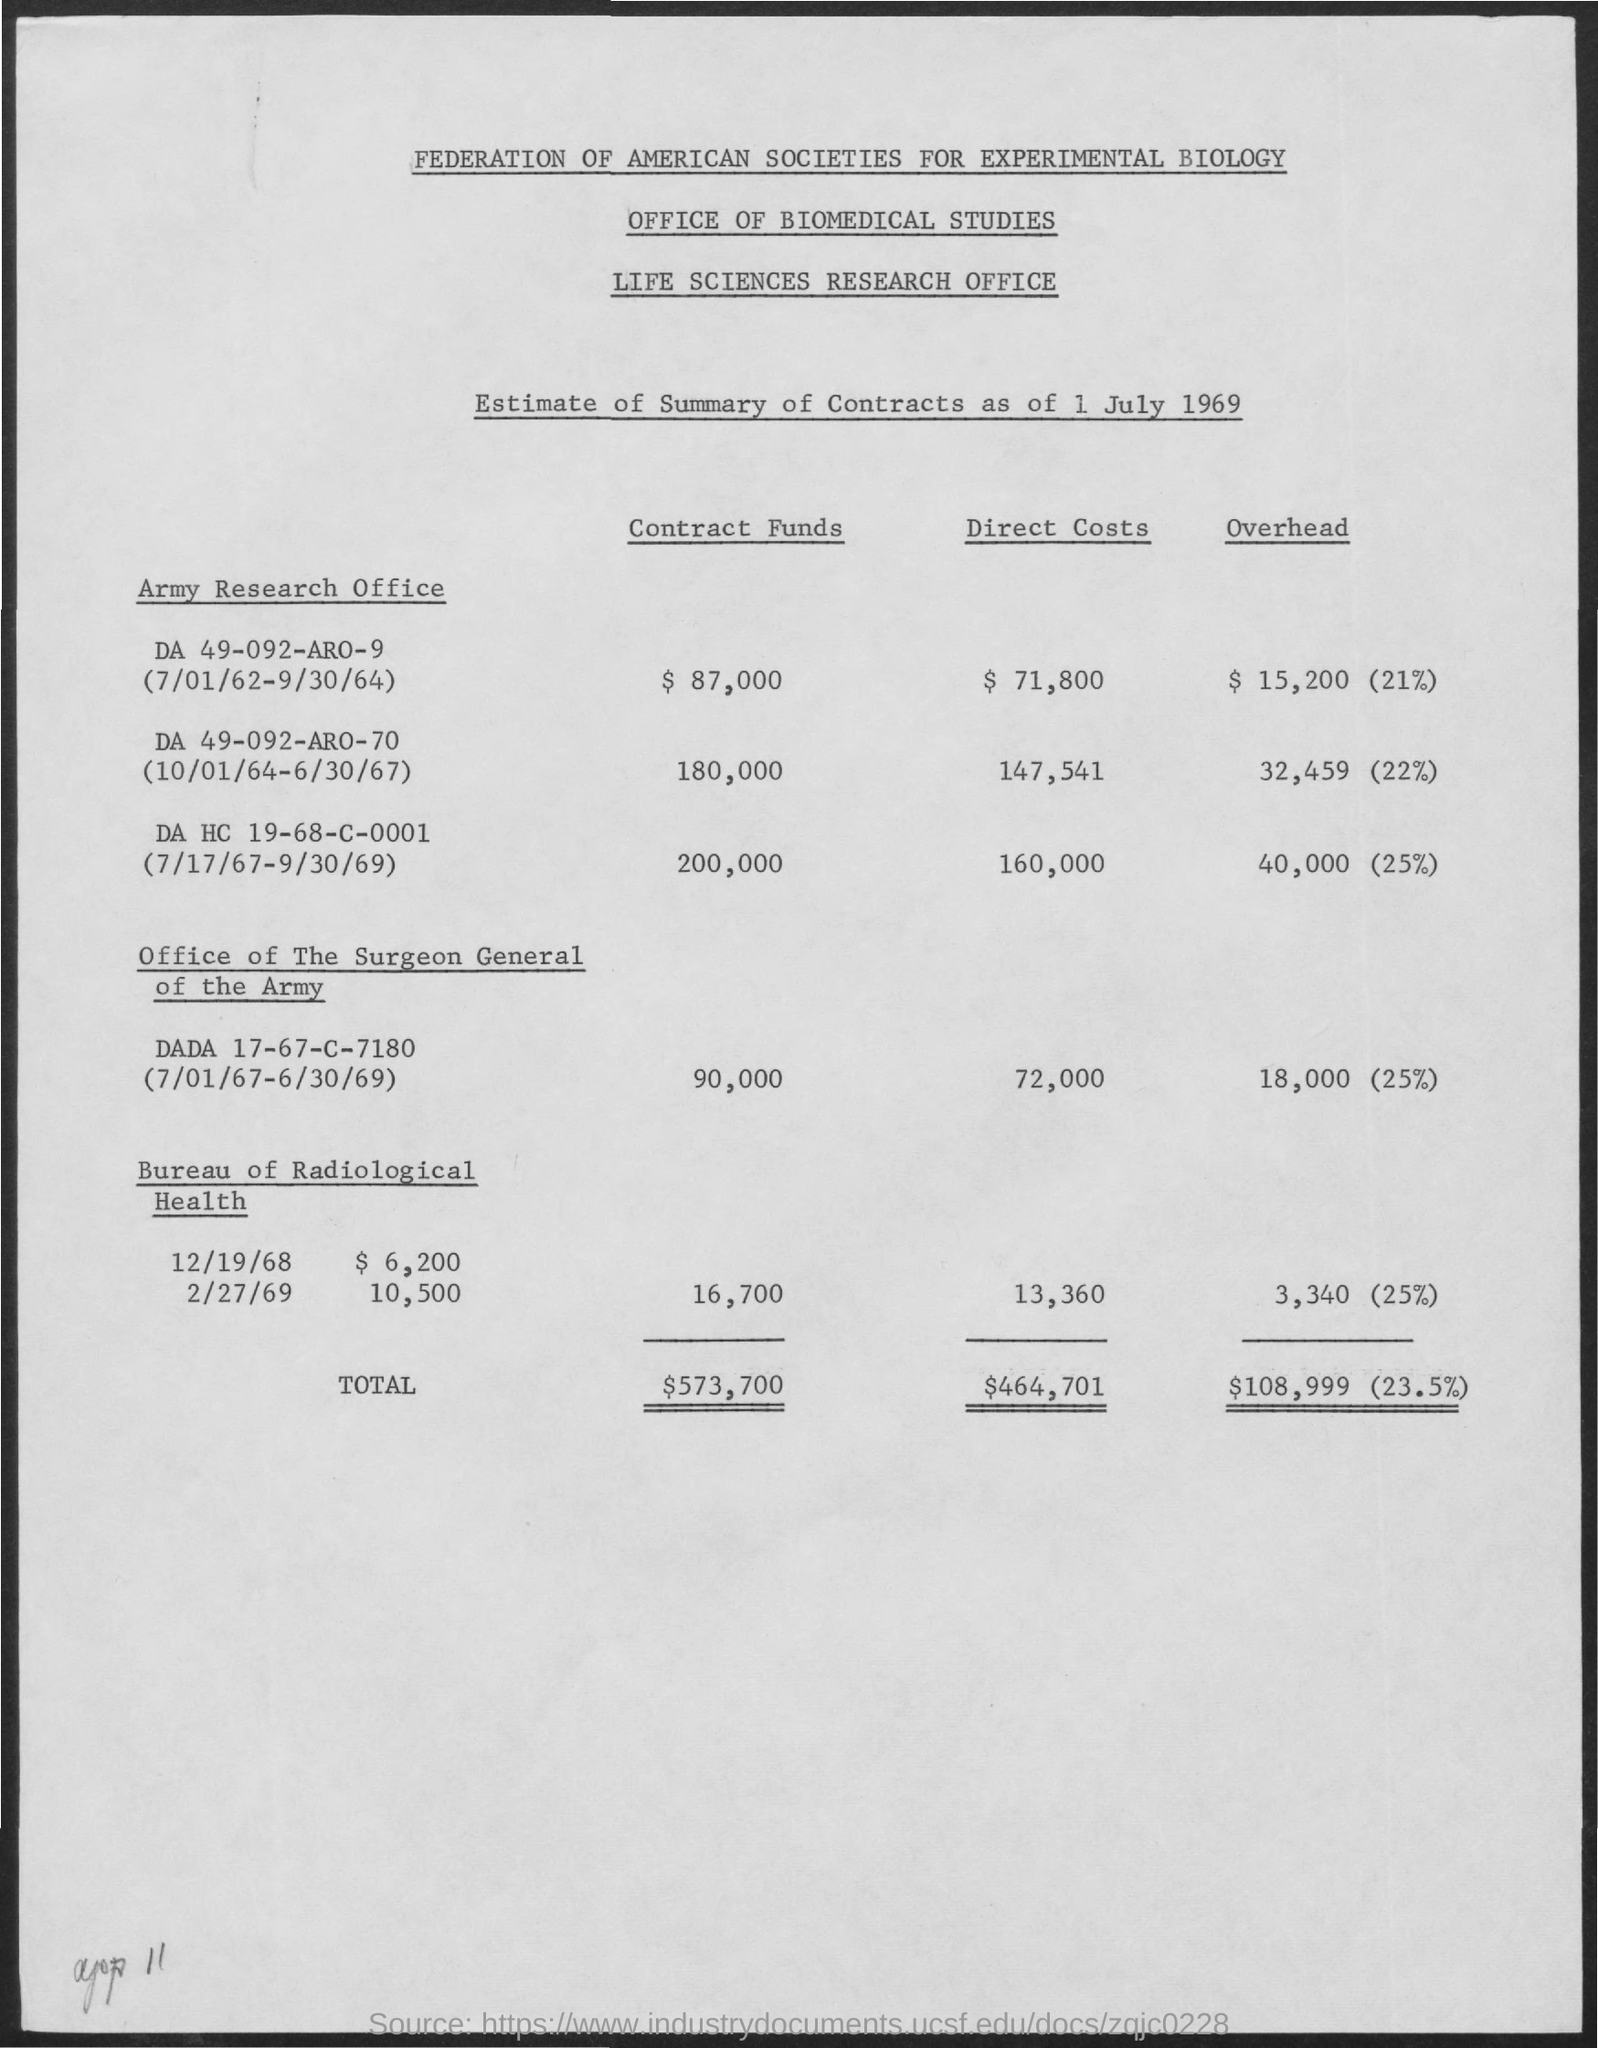What is the first title in the document?
Your response must be concise. Federation of american societies for experimental biology. What is the second title in the document?
Offer a terse response. Office of biomedical studies. What is the third title in the document?
Make the answer very short. Life sciences research office. What is the total direct costs?
Your answer should be compact. $464,701. 